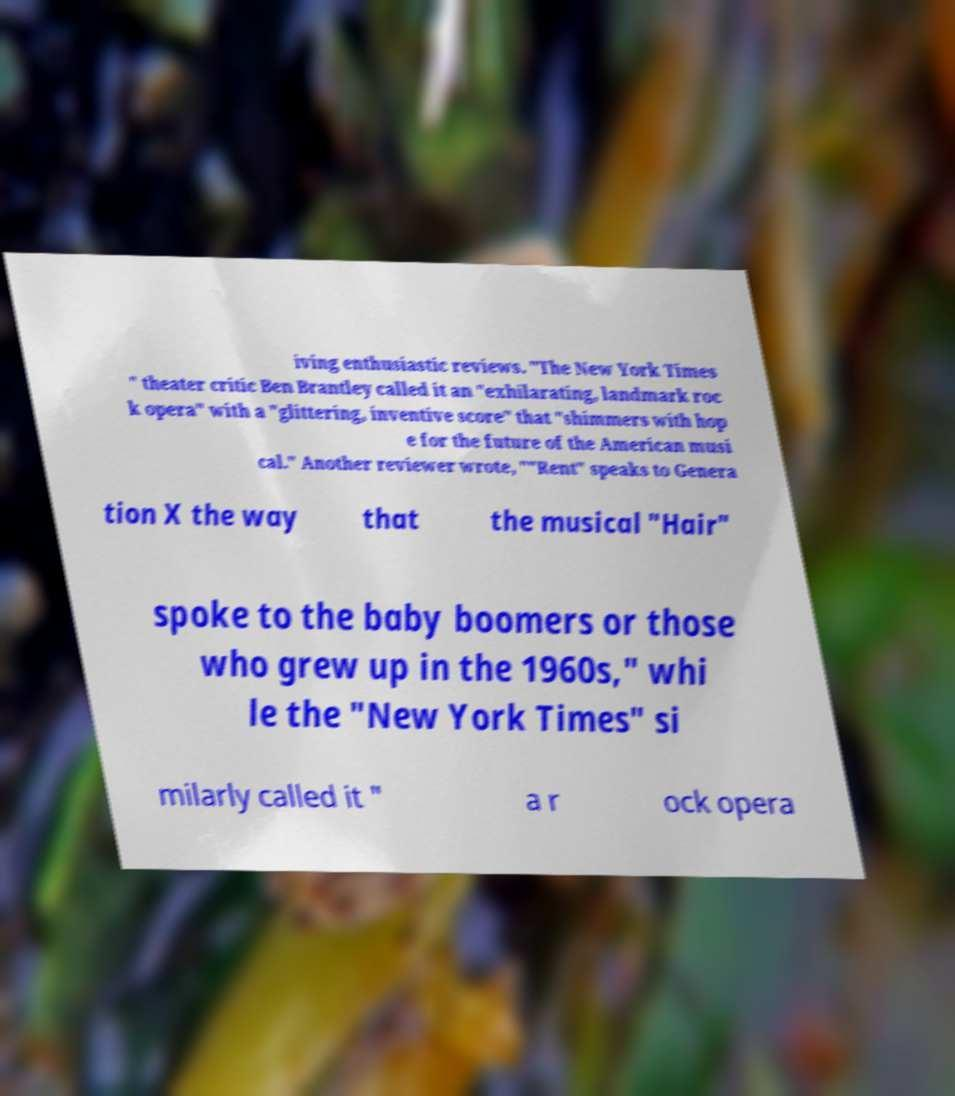For documentation purposes, I need the text within this image transcribed. Could you provide that? iving enthusiastic reviews. "The New York Times " theater critic Ben Brantley called it an "exhilarating, landmark roc k opera" with a "glittering, inventive score" that "shimmers with hop e for the future of the American musi cal." Another reviewer wrote, ""Rent" speaks to Genera tion X the way that the musical "Hair" spoke to the baby boomers or those who grew up in the 1960s," whi le the "New York Times" si milarly called it " a r ock opera 